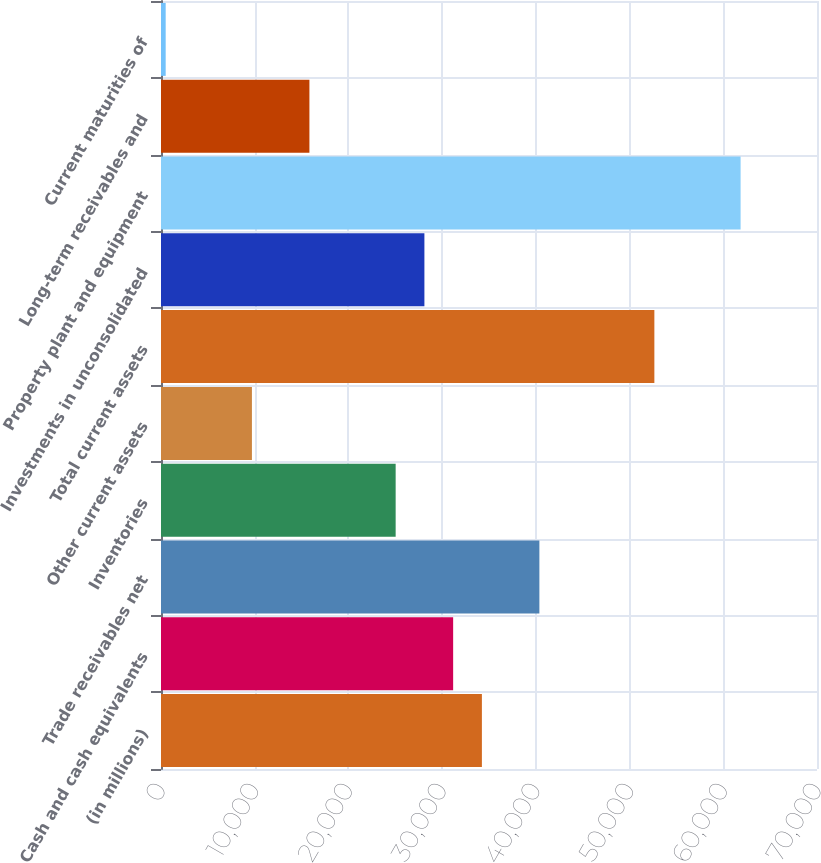<chart> <loc_0><loc_0><loc_500><loc_500><bar_chart><fcel>(in millions)<fcel>Cash and cash equivalents<fcel>Trade receivables net<fcel>Inventories<fcel>Other current assets<fcel>Total current assets<fcel>Investments in unconsolidated<fcel>Property plant and equipment<fcel>Long-term receivables and<fcel>Current maturities of<nl><fcel>34241.4<fcel>31174<fcel>40376.2<fcel>25039.2<fcel>9702.2<fcel>52645.8<fcel>28106.6<fcel>61848<fcel>15837<fcel>500<nl></chart> 